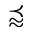Convert formula to latex. <formula><loc_0><loc_0><loc_500><loc_500>\prec a p p r o x</formula> 